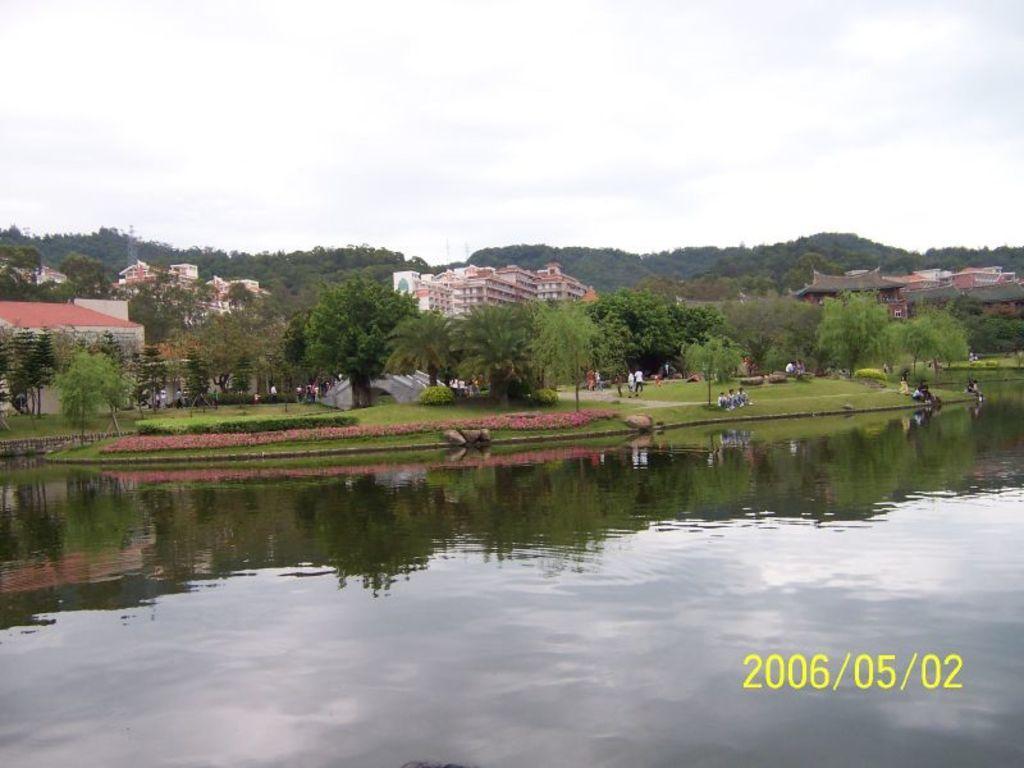In one or two sentences, can you explain what this image depicts? In the background we can see sky, trees and buildings. Here we can see people sitting and walking. Here we can see plants, grass and water. At the bottom right corner of the image there is a date. 